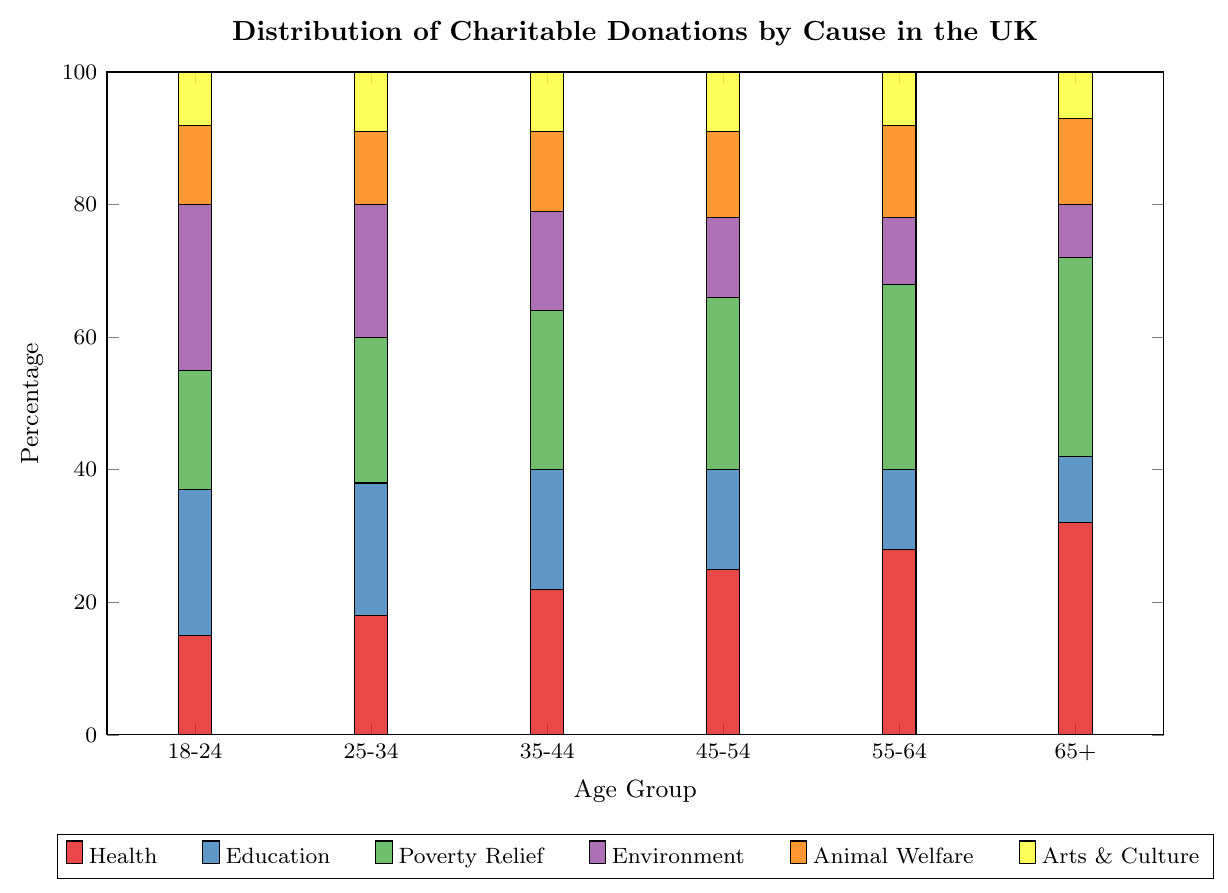Which age group donates the highest percentage to Health causes? The bar labeled for the "Health" cause should be visually identified for each age group. The 65+ age group has the highest bar for Health donations.
Answer: 65+ Which age group has the lowest percentage donation to Arts & Culture? The bar labeled "Arts & Culture" should be inspected for each age group. The smallest bar for Arts & Culture donations is in the 65+ age group.
Answer: 65+ What is the total percentage of donations by the 25-34 age group across all causes? Add the heights of all the bars corresponding to the 25-34 age group. The calculation is 18 (Health) + 20 (Education) + 22 (Poverty Relief) + 20 (Environment) + 11 (Animal Welfare) + 9 (Arts & Culture) = 100%.
Answer: 100% Which two age groups have equal percentages of donations to Animal Welfare? Identify the bars labeled "Animal Welfare" for all age groups. The age groups 35-44 and 55-64 both have bars of equal height (12) for Animal Welfare donations.
Answer: 35-44, 55-64 How much higher are Health donations by the 55-64 age group compared to the 18-24 age group? Identify and subtract the heights of the Health bars for the 18-24 and 55-64 age groups. Health donations for 55-64 are 28, and 18-24 are 15. The difference is 28 - 15 = 13.
Answer: 13 Which age group has a higher percentage of donations to Environment: 25-34 or 45-54? Compare the heights of the Environment bars for the 25-34 and 45-54 age groups. 25-34 age group has a bar of height 20, and 45-54 has a bar of height 12. Thus, 25-34 has a higher percentage.
Answer: 25-34 What's the average donation percentage to Education across all age groups? Add the heights of the Education bars across all age groups and divide by the number of age groups. The calculation is (22 + 20 + 18 + 15 + 12 + 10) / 6 = 16.17%.
Answer: 16.17% Which cause has the most variation in donation percentages across age groups? Visually inspect the ranges of the bars for each cause across all age groups. Health donations range from 15% to 32%, which is the largest range (17%).
Answer: Health In which age group are donations to Poverty Relief the highest? Inspect the heights of the Poverty Relief bars across all age groups. The highest bar for Poverty Relief donations is in the 65+ age group.
Answer: 65+ What is the sum of percentages of donations to Environment and Animal Welfare by the 35-44 age group? Add the heights of the Environment and Animal Welfare bars for the 35-44 age group. The calculation is 15 (Environment) + 12 (Animal Welfare) = 27.
Answer: 27 